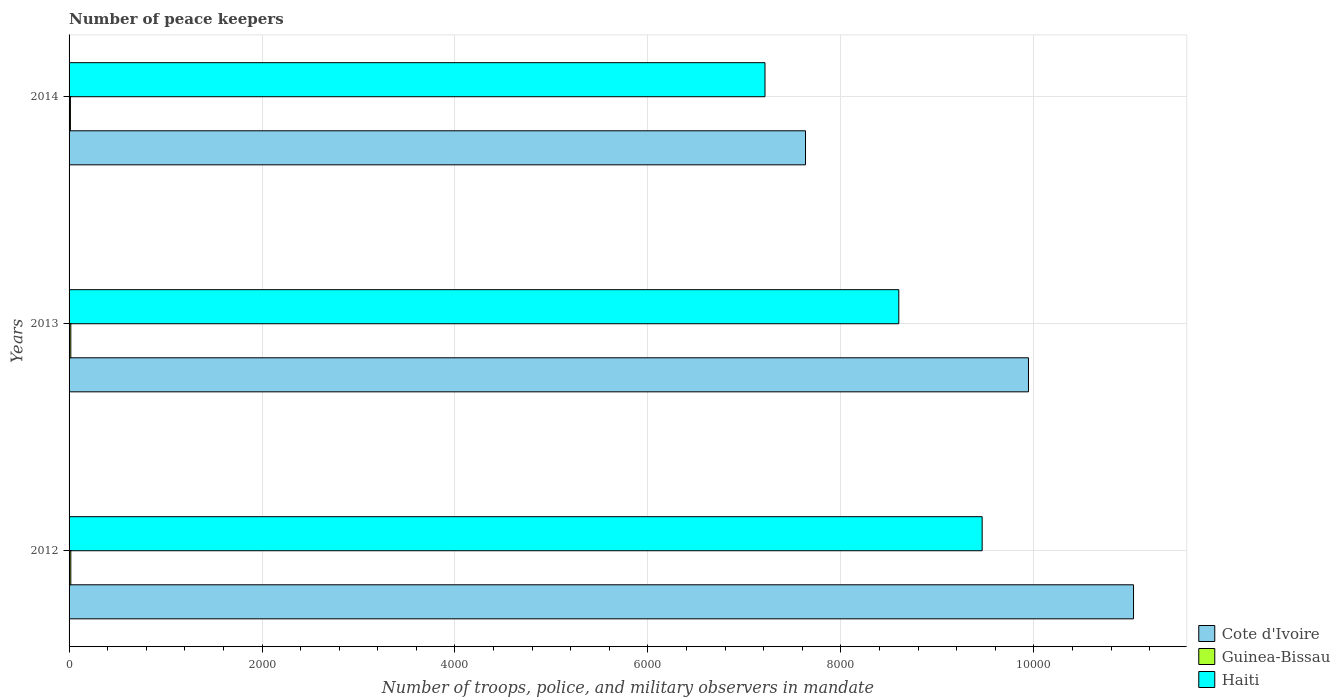Are the number of bars on each tick of the Y-axis equal?
Your response must be concise. Yes. How many bars are there on the 3rd tick from the bottom?
Your response must be concise. 3. What is the number of peace keepers in in Cote d'Ivoire in 2013?
Your response must be concise. 9944. Across all years, what is the maximum number of peace keepers in in Haiti?
Give a very brief answer. 9464. Across all years, what is the minimum number of peace keepers in in Haiti?
Offer a terse response. 7213. In which year was the number of peace keepers in in Cote d'Ivoire maximum?
Give a very brief answer. 2012. What is the total number of peace keepers in in Cote d'Ivoire in the graph?
Provide a succinct answer. 2.86e+04. What is the difference between the number of peace keepers in in Haiti in 2012 and that in 2014?
Your answer should be compact. 2251. What is the difference between the number of peace keepers in in Cote d'Ivoire in 2014 and the number of peace keepers in in Haiti in 2013?
Offer a very short reply. -967. What is the average number of peace keepers in in Guinea-Bissau per year?
Your answer should be very brief. 16.67. In the year 2013, what is the difference between the number of peace keepers in in Haiti and number of peace keepers in in Cote d'Ivoire?
Make the answer very short. -1344. In how many years, is the number of peace keepers in in Cote d'Ivoire greater than 2000 ?
Keep it short and to the point. 3. What is the ratio of the number of peace keepers in in Cote d'Ivoire in 2013 to that in 2014?
Keep it short and to the point. 1.3. What is the difference between the highest and the second highest number of peace keepers in in Cote d'Ivoire?
Give a very brief answer. 1089. What is the difference between the highest and the lowest number of peace keepers in in Cote d'Ivoire?
Give a very brief answer. 3400. In how many years, is the number of peace keepers in in Guinea-Bissau greater than the average number of peace keepers in in Guinea-Bissau taken over all years?
Make the answer very short. 2. What does the 1st bar from the top in 2013 represents?
Ensure brevity in your answer.  Haiti. What does the 3rd bar from the bottom in 2014 represents?
Provide a short and direct response. Haiti. Is it the case that in every year, the sum of the number of peace keepers in in Guinea-Bissau and number of peace keepers in in Cote d'Ivoire is greater than the number of peace keepers in in Haiti?
Your answer should be very brief. Yes. How many bars are there?
Your response must be concise. 9. Are all the bars in the graph horizontal?
Ensure brevity in your answer.  Yes. How many years are there in the graph?
Provide a short and direct response. 3. What is the difference between two consecutive major ticks on the X-axis?
Provide a short and direct response. 2000. Are the values on the major ticks of X-axis written in scientific E-notation?
Keep it short and to the point. No. Does the graph contain any zero values?
Offer a very short reply. No. Does the graph contain grids?
Your response must be concise. Yes. Where does the legend appear in the graph?
Provide a succinct answer. Bottom right. How are the legend labels stacked?
Your answer should be compact. Vertical. What is the title of the graph?
Your answer should be very brief. Number of peace keepers. What is the label or title of the X-axis?
Make the answer very short. Number of troops, police, and military observers in mandate. What is the label or title of the Y-axis?
Provide a short and direct response. Years. What is the Number of troops, police, and military observers in mandate in Cote d'Ivoire in 2012?
Your answer should be very brief. 1.10e+04. What is the Number of troops, police, and military observers in mandate in Guinea-Bissau in 2012?
Ensure brevity in your answer.  18. What is the Number of troops, police, and military observers in mandate of Haiti in 2012?
Offer a terse response. 9464. What is the Number of troops, police, and military observers in mandate of Cote d'Ivoire in 2013?
Your answer should be very brief. 9944. What is the Number of troops, police, and military observers in mandate of Haiti in 2013?
Make the answer very short. 8600. What is the Number of troops, police, and military observers in mandate in Cote d'Ivoire in 2014?
Your answer should be very brief. 7633. What is the Number of troops, police, and military observers in mandate in Guinea-Bissau in 2014?
Give a very brief answer. 14. What is the Number of troops, police, and military observers in mandate of Haiti in 2014?
Give a very brief answer. 7213. Across all years, what is the maximum Number of troops, police, and military observers in mandate of Cote d'Ivoire?
Give a very brief answer. 1.10e+04. Across all years, what is the maximum Number of troops, police, and military observers in mandate in Guinea-Bissau?
Provide a short and direct response. 18. Across all years, what is the maximum Number of troops, police, and military observers in mandate of Haiti?
Ensure brevity in your answer.  9464. Across all years, what is the minimum Number of troops, police, and military observers in mandate in Cote d'Ivoire?
Provide a succinct answer. 7633. Across all years, what is the minimum Number of troops, police, and military observers in mandate of Guinea-Bissau?
Ensure brevity in your answer.  14. Across all years, what is the minimum Number of troops, police, and military observers in mandate of Haiti?
Offer a terse response. 7213. What is the total Number of troops, police, and military observers in mandate of Cote d'Ivoire in the graph?
Provide a succinct answer. 2.86e+04. What is the total Number of troops, police, and military observers in mandate of Haiti in the graph?
Provide a succinct answer. 2.53e+04. What is the difference between the Number of troops, police, and military observers in mandate of Cote d'Ivoire in 2012 and that in 2013?
Give a very brief answer. 1089. What is the difference between the Number of troops, police, and military observers in mandate in Guinea-Bissau in 2012 and that in 2013?
Ensure brevity in your answer.  0. What is the difference between the Number of troops, police, and military observers in mandate of Haiti in 2012 and that in 2013?
Offer a terse response. 864. What is the difference between the Number of troops, police, and military observers in mandate of Cote d'Ivoire in 2012 and that in 2014?
Offer a very short reply. 3400. What is the difference between the Number of troops, police, and military observers in mandate of Guinea-Bissau in 2012 and that in 2014?
Give a very brief answer. 4. What is the difference between the Number of troops, police, and military observers in mandate of Haiti in 2012 and that in 2014?
Your response must be concise. 2251. What is the difference between the Number of troops, police, and military observers in mandate in Cote d'Ivoire in 2013 and that in 2014?
Give a very brief answer. 2311. What is the difference between the Number of troops, police, and military observers in mandate in Guinea-Bissau in 2013 and that in 2014?
Your response must be concise. 4. What is the difference between the Number of troops, police, and military observers in mandate of Haiti in 2013 and that in 2014?
Your answer should be compact. 1387. What is the difference between the Number of troops, police, and military observers in mandate of Cote d'Ivoire in 2012 and the Number of troops, police, and military observers in mandate of Guinea-Bissau in 2013?
Provide a short and direct response. 1.10e+04. What is the difference between the Number of troops, police, and military observers in mandate of Cote d'Ivoire in 2012 and the Number of troops, police, and military observers in mandate of Haiti in 2013?
Provide a short and direct response. 2433. What is the difference between the Number of troops, police, and military observers in mandate in Guinea-Bissau in 2012 and the Number of troops, police, and military observers in mandate in Haiti in 2013?
Make the answer very short. -8582. What is the difference between the Number of troops, police, and military observers in mandate of Cote d'Ivoire in 2012 and the Number of troops, police, and military observers in mandate of Guinea-Bissau in 2014?
Provide a short and direct response. 1.10e+04. What is the difference between the Number of troops, police, and military observers in mandate in Cote d'Ivoire in 2012 and the Number of troops, police, and military observers in mandate in Haiti in 2014?
Your response must be concise. 3820. What is the difference between the Number of troops, police, and military observers in mandate in Guinea-Bissau in 2012 and the Number of troops, police, and military observers in mandate in Haiti in 2014?
Provide a succinct answer. -7195. What is the difference between the Number of troops, police, and military observers in mandate in Cote d'Ivoire in 2013 and the Number of troops, police, and military observers in mandate in Guinea-Bissau in 2014?
Your response must be concise. 9930. What is the difference between the Number of troops, police, and military observers in mandate in Cote d'Ivoire in 2013 and the Number of troops, police, and military observers in mandate in Haiti in 2014?
Keep it short and to the point. 2731. What is the difference between the Number of troops, police, and military observers in mandate of Guinea-Bissau in 2013 and the Number of troops, police, and military observers in mandate of Haiti in 2014?
Provide a short and direct response. -7195. What is the average Number of troops, police, and military observers in mandate in Cote d'Ivoire per year?
Offer a very short reply. 9536.67. What is the average Number of troops, police, and military observers in mandate of Guinea-Bissau per year?
Your answer should be very brief. 16.67. What is the average Number of troops, police, and military observers in mandate of Haiti per year?
Provide a short and direct response. 8425.67. In the year 2012, what is the difference between the Number of troops, police, and military observers in mandate of Cote d'Ivoire and Number of troops, police, and military observers in mandate of Guinea-Bissau?
Offer a terse response. 1.10e+04. In the year 2012, what is the difference between the Number of troops, police, and military observers in mandate of Cote d'Ivoire and Number of troops, police, and military observers in mandate of Haiti?
Keep it short and to the point. 1569. In the year 2012, what is the difference between the Number of troops, police, and military observers in mandate in Guinea-Bissau and Number of troops, police, and military observers in mandate in Haiti?
Keep it short and to the point. -9446. In the year 2013, what is the difference between the Number of troops, police, and military observers in mandate in Cote d'Ivoire and Number of troops, police, and military observers in mandate in Guinea-Bissau?
Your answer should be very brief. 9926. In the year 2013, what is the difference between the Number of troops, police, and military observers in mandate in Cote d'Ivoire and Number of troops, police, and military observers in mandate in Haiti?
Your answer should be compact. 1344. In the year 2013, what is the difference between the Number of troops, police, and military observers in mandate of Guinea-Bissau and Number of troops, police, and military observers in mandate of Haiti?
Make the answer very short. -8582. In the year 2014, what is the difference between the Number of troops, police, and military observers in mandate of Cote d'Ivoire and Number of troops, police, and military observers in mandate of Guinea-Bissau?
Provide a short and direct response. 7619. In the year 2014, what is the difference between the Number of troops, police, and military observers in mandate of Cote d'Ivoire and Number of troops, police, and military observers in mandate of Haiti?
Your answer should be compact. 420. In the year 2014, what is the difference between the Number of troops, police, and military observers in mandate of Guinea-Bissau and Number of troops, police, and military observers in mandate of Haiti?
Make the answer very short. -7199. What is the ratio of the Number of troops, police, and military observers in mandate of Cote d'Ivoire in 2012 to that in 2013?
Offer a terse response. 1.11. What is the ratio of the Number of troops, police, and military observers in mandate in Haiti in 2012 to that in 2013?
Your answer should be very brief. 1.1. What is the ratio of the Number of troops, police, and military observers in mandate in Cote d'Ivoire in 2012 to that in 2014?
Offer a terse response. 1.45. What is the ratio of the Number of troops, police, and military observers in mandate of Haiti in 2012 to that in 2014?
Your response must be concise. 1.31. What is the ratio of the Number of troops, police, and military observers in mandate of Cote d'Ivoire in 2013 to that in 2014?
Your response must be concise. 1.3. What is the ratio of the Number of troops, police, and military observers in mandate of Guinea-Bissau in 2013 to that in 2014?
Ensure brevity in your answer.  1.29. What is the ratio of the Number of troops, police, and military observers in mandate in Haiti in 2013 to that in 2014?
Give a very brief answer. 1.19. What is the difference between the highest and the second highest Number of troops, police, and military observers in mandate in Cote d'Ivoire?
Keep it short and to the point. 1089. What is the difference between the highest and the second highest Number of troops, police, and military observers in mandate in Haiti?
Ensure brevity in your answer.  864. What is the difference between the highest and the lowest Number of troops, police, and military observers in mandate in Cote d'Ivoire?
Your answer should be compact. 3400. What is the difference between the highest and the lowest Number of troops, police, and military observers in mandate of Guinea-Bissau?
Provide a short and direct response. 4. What is the difference between the highest and the lowest Number of troops, police, and military observers in mandate in Haiti?
Make the answer very short. 2251. 